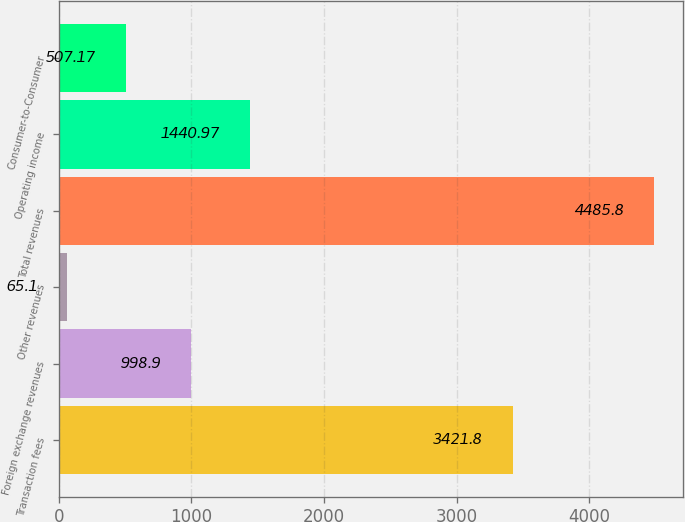<chart> <loc_0><loc_0><loc_500><loc_500><bar_chart><fcel>Transaction fees<fcel>Foreign exchange revenues<fcel>Other revenues<fcel>Total revenues<fcel>Operating income<fcel>Consumer-to-Consumer<nl><fcel>3421.8<fcel>998.9<fcel>65.1<fcel>4485.8<fcel>1440.97<fcel>507.17<nl></chart> 